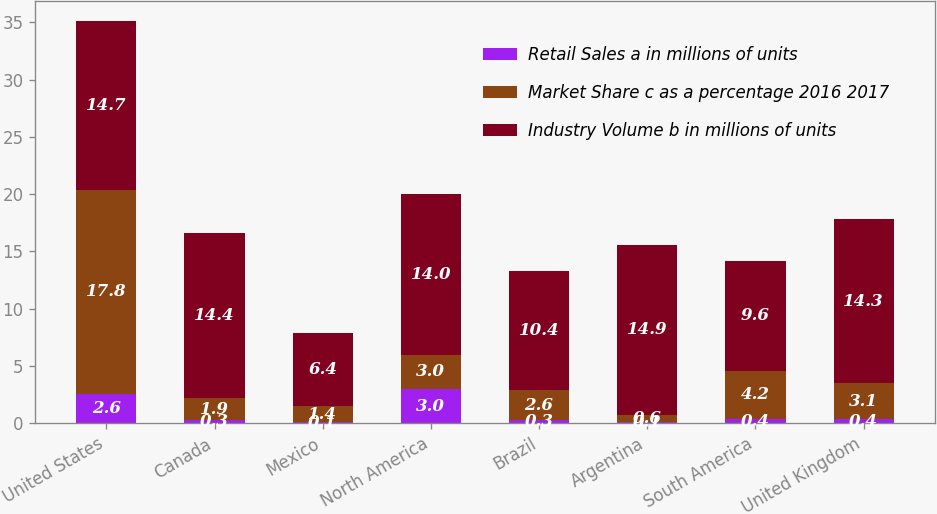Convert chart. <chart><loc_0><loc_0><loc_500><loc_500><stacked_bar_chart><ecel><fcel>United States<fcel>Canada<fcel>Mexico<fcel>North America<fcel>Brazil<fcel>Argentina<fcel>South America<fcel>United Kingdom<nl><fcel>Retail Sales a in millions of units<fcel>2.6<fcel>0.3<fcel>0.1<fcel>3<fcel>0.3<fcel>0.1<fcel>0.4<fcel>0.4<nl><fcel>Market Share c as a percentage 2016 2017<fcel>17.8<fcel>1.9<fcel>1.4<fcel>3<fcel>2.6<fcel>0.6<fcel>4.2<fcel>3.1<nl><fcel>Industry Volume b in millions of units<fcel>14.7<fcel>14.4<fcel>6.4<fcel>14<fcel>10.4<fcel>14.9<fcel>9.6<fcel>14.3<nl></chart> 